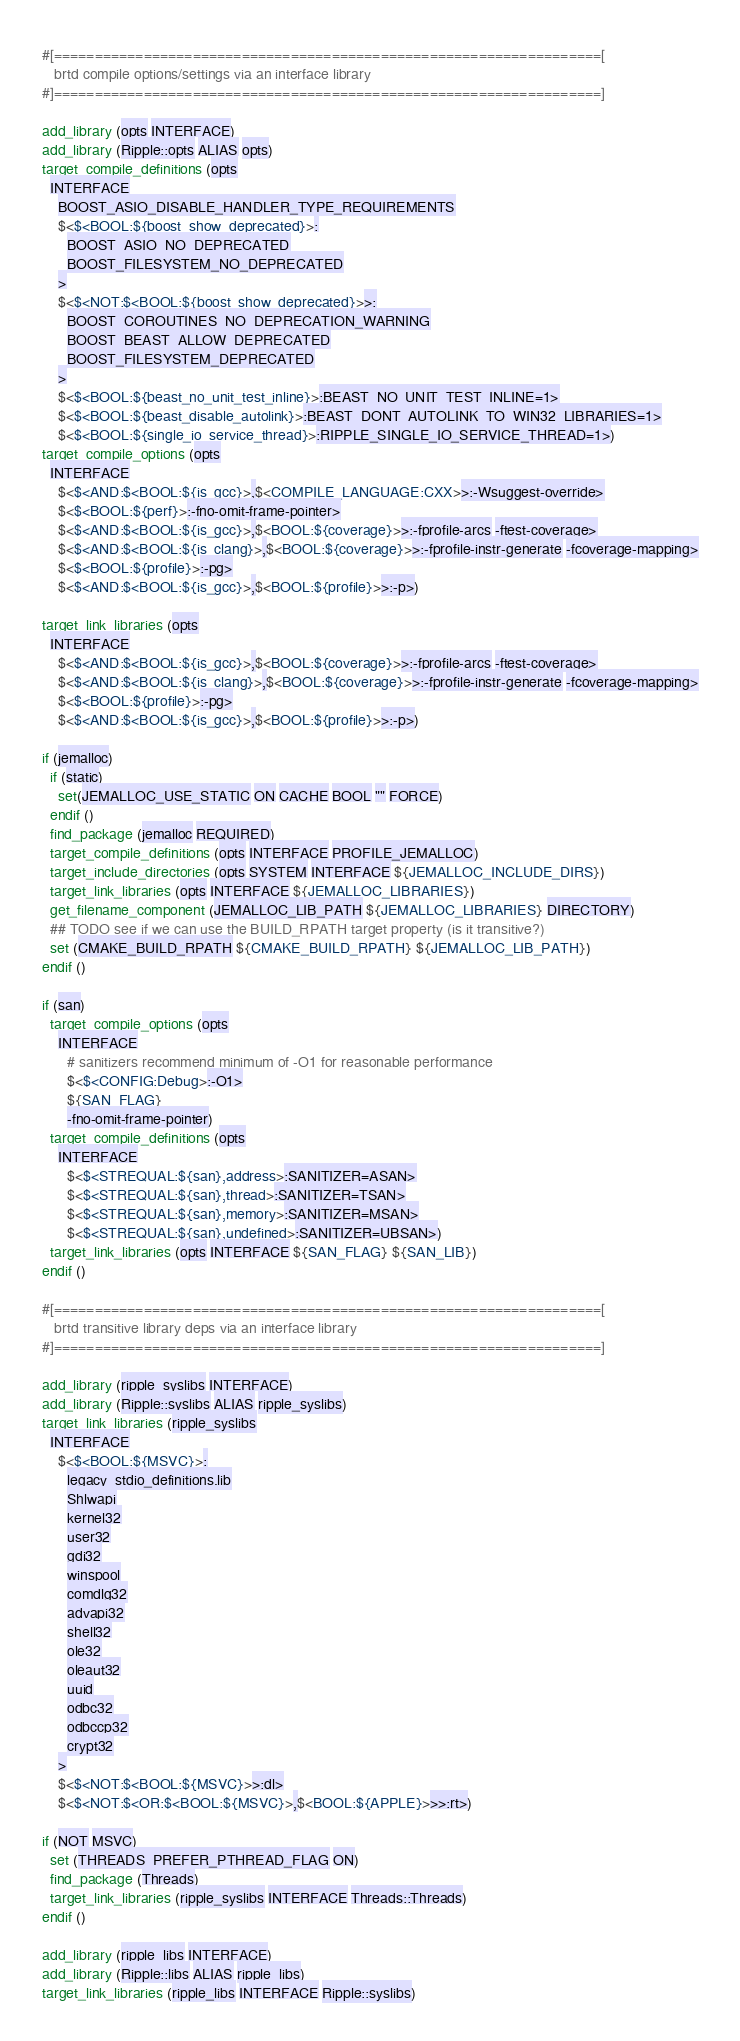<code> <loc_0><loc_0><loc_500><loc_500><_CMake_>#[===================================================================[
   brtd compile options/settings via an interface library
#]===================================================================]

add_library (opts INTERFACE)
add_library (Ripple::opts ALIAS opts)
target_compile_definitions (opts
  INTERFACE
    BOOST_ASIO_DISABLE_HANDLER_TYPE_REQUIREMENTS
    $<$<BOOL:${boost_show_deprecated}>:
      BOOST_ASIO_NO_DEPRECATED
      BOOST_FILESYSTEM_NO_DEPRECATED
    >
    $<$<NOT:$<BOOL:${boost_show_deprecated}>>:
      BOOST_COROUTINES_NO_DEPRECATION_WARNING
      BOOST_BEAST_ALLOW_DEPRECATED
      BOOST_FILESYSTEM_DEPRECATED
    >
    $<$<BOOL:${beast_no_unit_test_inline}>:BEAST_NO_UNIT_TEST_INLINE=1>
    $<$<BOOL:${beast_disable_autolink}>:BEAST_DONT_AUTOLINK_TO_WIN32_LIBRARIES=1>
    $<$<BOOL:${single_io_service_thread}>:RIPPLE_SINGLE_IO_SERVICE_THREAD=1>)
target_compile_options (opts
  INTERFACE
    $<$<AND:$<BOOL:${is_gcc}>,$<COMPILE_LANGUAGE:CXX>>:-Wsuggest-override>
    $<$<BOOL:${perf}>:-fno-omit-frame-pointer>
    $<$<AND:$<BOOL:${is_gcc}>,$<BOOL:${coverage}>>:-fprofile-arcs -ftest-coverage>
    $<$<AND:$<BOOL:${is_clang}>,$<BOOL:${coverage}>>:-fprofile-instr-generate -fcoverage-mapping>
    $<$<BOOL:${profile}>:-pg>
    $<$<AND:$<BOOL:${is_gcc}>,$<BOOL:${profile}>>:-p>)

target_link_libraries (opts
  INTERFACE
    $<$<AND:$<BOOL:${is_gcc}>,$<BOOL:${coverage}>>:-fprofile-arcs -ftest-coverage>
    $<$<AND:$<BOOL:${is_clang}>,$<BOOL:${coverage}>>:-fprofile-instr-generate -fcoverage-mapping>
    $<$<BOOL:${profile}>:-pg>
    $<$<AND:$<BOOL:${is_gcc}>,$<BOOL:${profile}>>:-p>)

if (jemalloc)
  if (static)
    set(JEMALLOC_USE_STATIC ON CACHE BOOL "" FORCE)
  endif ()
  find_package (jemalloc REQUIRED)
  target_compile_definitions (opts INTERFACE PROFILE_JEMALLOC)
  target_include_directories (opts SYSTEM INTERFACE ${JEMALLOC_INCLUDE_DIRS})
  target_link_libraries (opts INTERFACE ${JEMALLOC_LIBRARIES})
  get_filename_component (JEMALLOC_LIB_PATH ${JEMALLOC_LIBRARIES} DIRECTORY)
  ## TODO see if we can use the BUILD_RPATH target property (is it transitive?)
  set (CMAKE_BUILD_RPATH ${CMAKE_BUILD_RPATH} ${JEMALLOC_LIB_PATH})
endif ()

if (san)
  target_compile_options (opts
    INTERFACE
      # sanitizers recommend minimum of -O1 for reasonable performance
      $<$<CONFIG:Debug>:-O1>
      ${SAN_FLAG}
      -fno-omit-frame-pointer)
  target_compile_definitions (opts
    INTERFACE
      $<$<STREQUAL:${san},address>:SANITIZER=ASAN>
      $<$<STREQUAL:${san},thread>:SANITIZER=TSAN>
      $<$<STREQUAL:${san},memory>:SANITIZER=MSAN>
      $<$<STREQUAL:${san},undefined>:SANITIZER=UBSAN>)
  target_link_libraries (opts INTERFACE ${SAN_FLAG} ${SAN_LIB})
endif ()

#[===================================================================[
   brtd transitive library deps via an interface library
#]===================================================================]

add_library (ripple_syslibs INTERFACE)
add_library (Ripple::syslibs ALIAS ripple_syslibs)
target_link_libraries (ripple_syslibs
  INTERFACE
    $<$<BOOL:${MSVC}>:
      legacy_stdio_definitions.lib
      Shlwapi
      kernel32
      user32
      gdi32
      winspool
      comdlg32
      advapi32
      shell32
      ole32
      oleaut32
      uuid
      odbc32
      odbccp32
      crypt32
    >
    $<$<NOT:$<BOOL:${MSVC}>>:dl>
    $<$<NOT:$<OR:$<BOOL:${MSVC}>,$<BOOL:${APPLE}>>>:rt>)

if (NOT MSVC)
  set (THREADS_PREFER_PTHREAD_FLAG ON)
  find_package (Threads)
  target_link_libraries (ripple_syslibs INTERFACE Threads::Threads)
endif ()

add_library (ripple_libs INTERFACE)
add_library (Ripple::libs ALIAS ripple_libs)
target_link_libraries (ripple_libs INTERFACE Ripple::syslibs)
</code> 